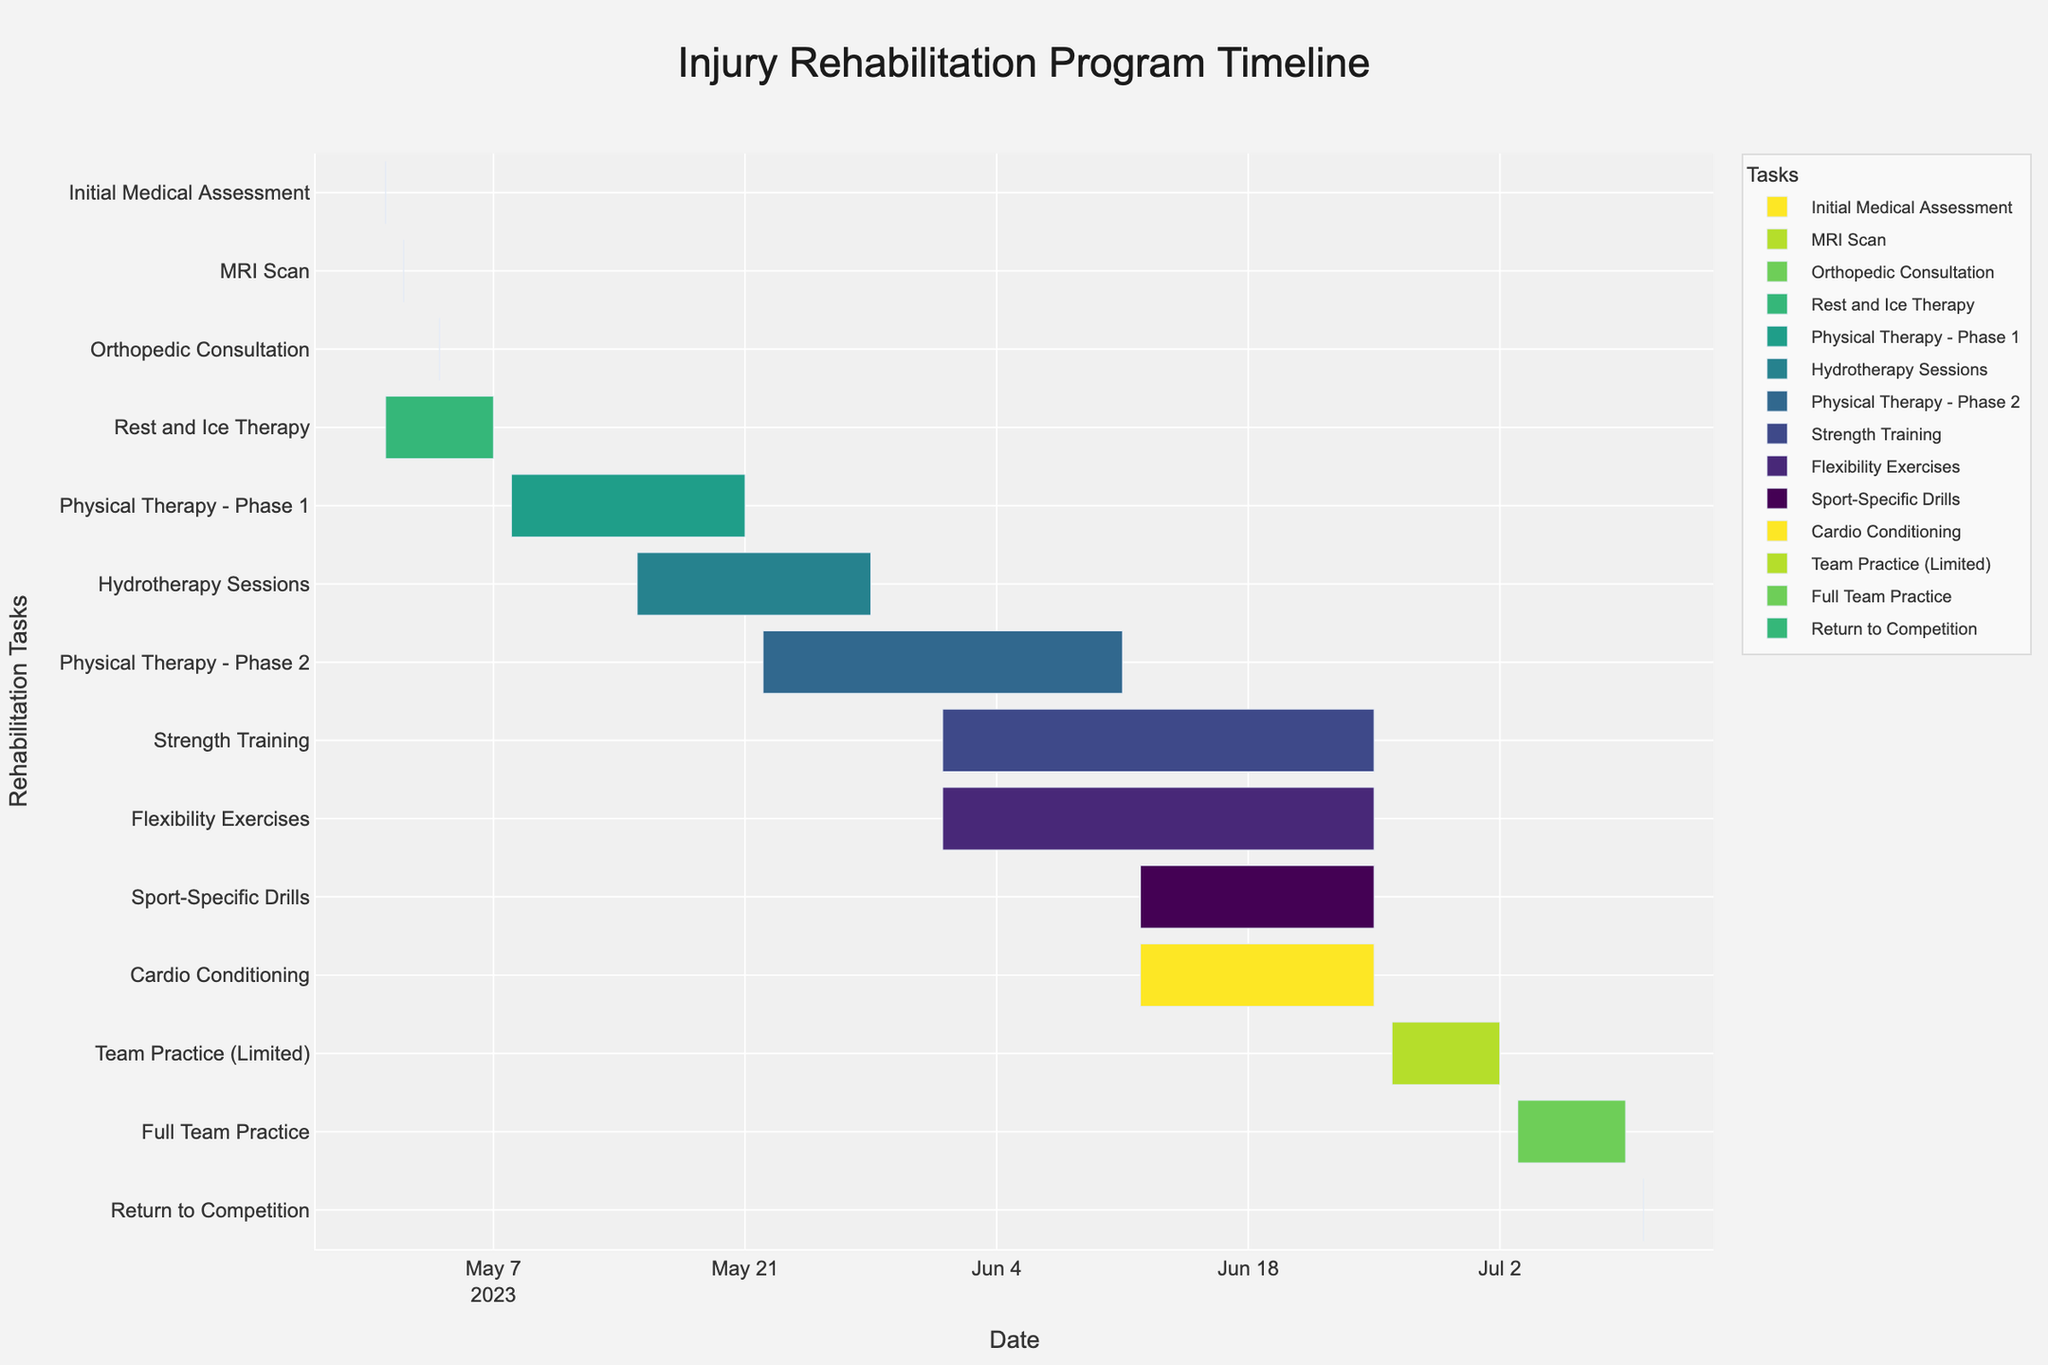When does the Initial Medical Assessment take place? The Gantt chart shows the timeline for each task. The Initial Medical Assessment is a single-day task.
Answer: May 1, 2023 How many days does Rest and Ice Therapy last? The Gantt chart indicates the start and end dates for each task. Rest and Ice Therapy starts on May 1, 2023, and ends on May 7, 2023. The duration is (May 7 - May 1) + 1 days.
Answer: 7 days Which tasks overlap with Physical Therapy - Phase 1? Physical Therapy - Phase 1 runs from May 8, 2023, to May 21, 2023. Any task with dates that fall within this range overlaps. Hydrotherapy Sessions overlap because they start on May 15, 2023, and end on May 28, 2023.
Answer: Hydrotherapy Sessions Which tasks run parallel to Strength Training? Strength Training runs from June 1, 2023, to June 25, 2023. Tasks within this range along the y-axis include Flexibility Exercises, Sport-Specific Drills, and Cardio Conditioning.
Answer: Flexibility Exercises, Sport-Specific Drills, Cardio Conditioning Which task has the shortest duration? The Gantt chart shows the duration of each task. Task durations are computed from the start and end dates. Initial Medical Assessment, MRI Scan, Orthopedic Consultation, and Return to Competition all have a duration of 1 day, making them the shortest.
Answer: Initial Medical Assessment, MRI Scan, Orthopedic Consultation, Return to Competition What is the total duration of all phases of Physical Therapy? Sum the durations of Physical Therapy - Phase 1 and Physical Therapy - Phase 2. Phase 1 is from May 8 to May 21 (14 days), and Phase 2 is from May 22 to June 11 (21 days). Total duration is 14 + 21.
Answer: 35 days How long is the break between Rest and Ice Therapy and Physical Therapy - Phase 1? Rest and Ice Therapy ends on May 7, 2023, and Physical Therapy - Phase 1 begins on May 8, 2023. There is no break between these tasks.
Answer: 0 days Which phase or session precedes Full Team Practice? Full Team Practice starts on July 3, 2023, and ends on July 9, 2023. The preceding task is Team Practice (Limited), which ends on July 2, 2023.
Answer: Team Practice (Limited) What is the duration of the entire rehabilitation program from the first to the last task? Determine the start and end dates of the entire program. The program starts with the Initial Medical Assessment on May 1, 2023, and ends with Return to Competition on July 10, 2023. The duration is from May 1 to July 10.
Answer: 71 days How many tasks are there that involve some form of therapy (e.g., Physical Therapy, Hydrotherapy)? Count the tasks named with "Therapy." They are Rest and Ice Therapy, Physical Therapy - Phase 1, Hydrotherapy Sessions, and Physical Therapy - Phase 2.
Answer: 4 tasks 